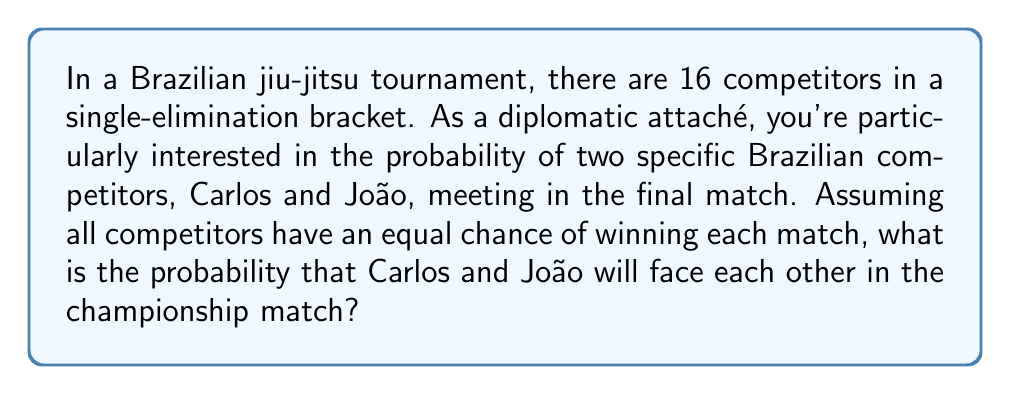Show me your answer to this math problem. Let's approach this step-by-step:

1) In a single-elimination tournament with 16 competitors, there are 4 rounds:
   - Round 1: 8 matches (16 competitors)
   - Round 2 (Quarter-finals): 4 matches (8 competitors)
   - Round 3 (Semi-finals): 2 matches (4 competitors)
   - Round 4 (Final): 1 match (2 competitors)

2) For Carlos and João to meet in the final, they must:
   a) Be on opposite sides of the bracket
   b) Win all their matches leading up to the final

3) The probability of Carlos and João being on opposite sides of the bracket:
   $$ P(\text{opposite sides}) = \frac{\binom{8}{1}}{\binom{15}{1}} = \frac{8}{15} $$

4) Given that they're on opposite sides, the probability of both reaching the final:
   Each must win 3 matches to reach the final.
   $$ P(\text{both reach final} | \text{opposite sides}) = (\frac{1}{2})^3 \cdot (\frac{1}{2})^3 = (\frac{1}{8})^2 = \frac{1}{64} $$

5) The total probability is the product of these two probabilities:
   $$ P(\text{meet in final}) = P(\text{opposite sides}) \cdot P(\text{both reach final} | \text{opposite sides}) $$
   $$ = \frac{8}{15} \cdot \frac{1}{64} = \frac{1}{120} $$

Therefore, the probability of Carlos and João meeting in the final match is $\frac{1}{120}$ or approximately 0.00833 or 0.833%.
Answer: $\frac{1}{120}$ 